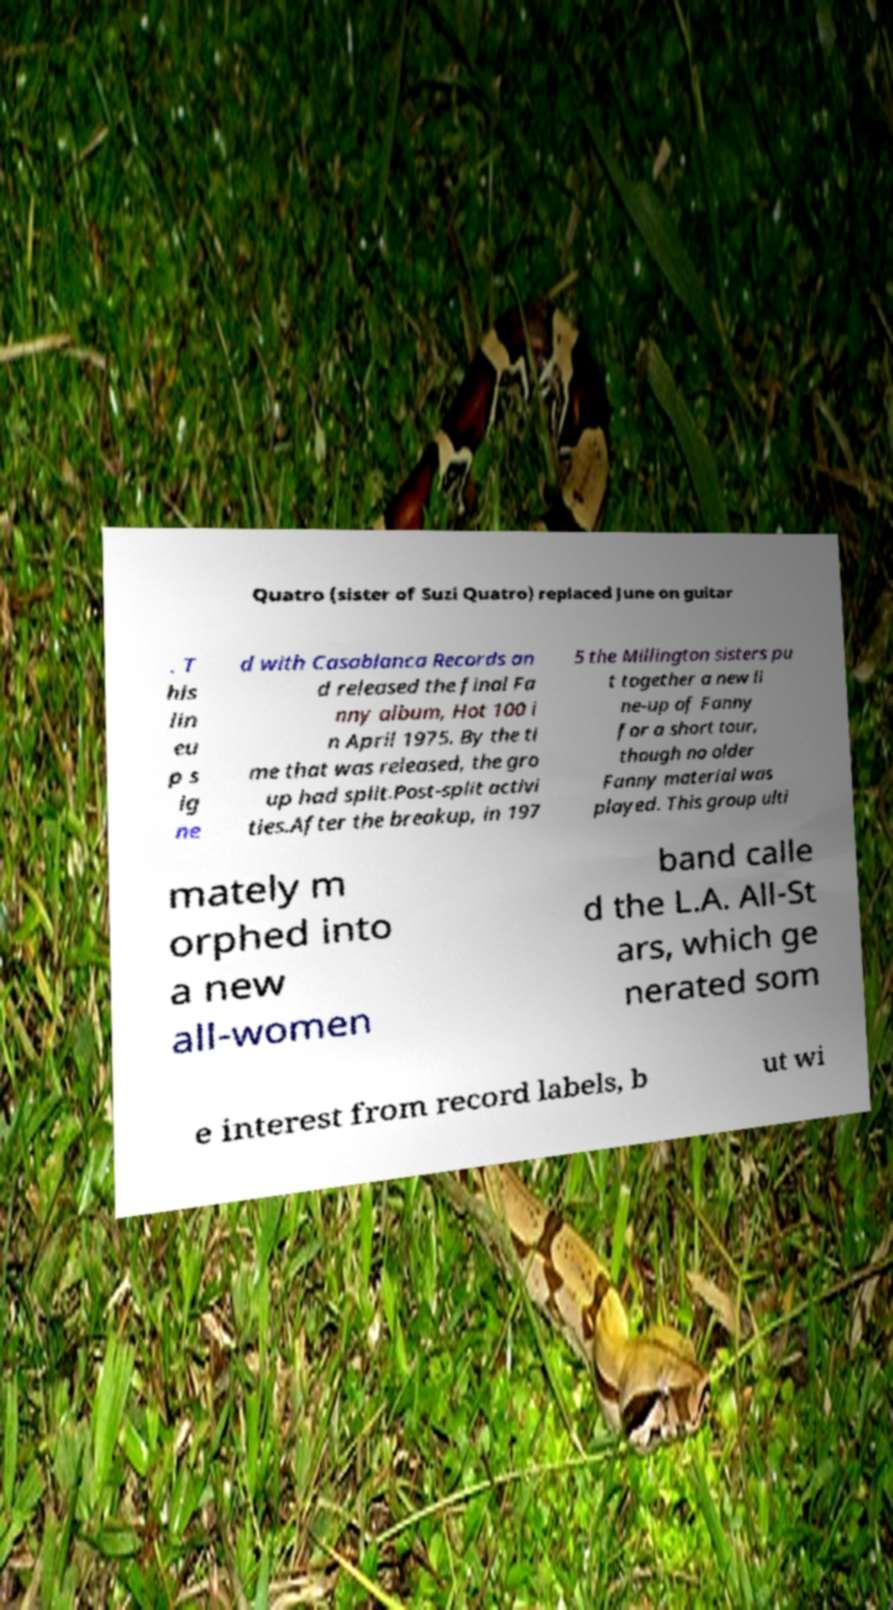Could you extract and type out the text from this image? Quatro (sister of Suzi Quatro) replaced June on guitar . T his lin eu p s ig ne d with Casablanca Records an d released the final Fa nny album, Hot 100 i n April 1975. By the ti me that was released, the gro up had split.Post-split activi ties.After the breakup, in 197 5 the Millington sisters pu t together a new li ne-up of Fanny for a short tour, though no older Fanny material was played. This group ulti mately m orphed into a new all-women band calle d the L.A. All-St ars, which ge nerated som e interest from record labels, b ut wi 